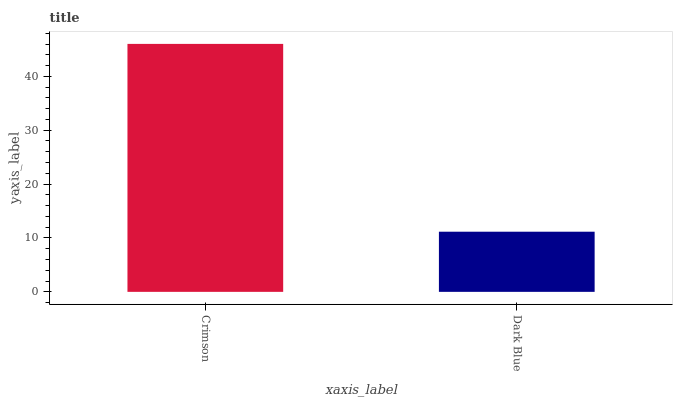Is Dark Blue the minimum?
Answer yes or no. Yes. Is Crimson the maximum?
Answer yes or no. Yes. Is Dark Blue the maximum?
Answer yes or no. No. Is Crimson greater than Dark Blue?
Answer yes or no. Yes. Is Dark Blue less than Crimson?
Answer yes or no. Yes. Is Dark Blue greater than Crimson?
Answer yes or no. No. Is Crimson less than Dark Blue?
Answer yes or no. No. Is Crimson the high median?
Answer yes or no. Yes. Is Dark Blue the low median?
Answer yes or no. Yes. Is Dark Blue the high median?
Answer yes or no. No. Is Crimson the low median?
Answer yes or no. No. 